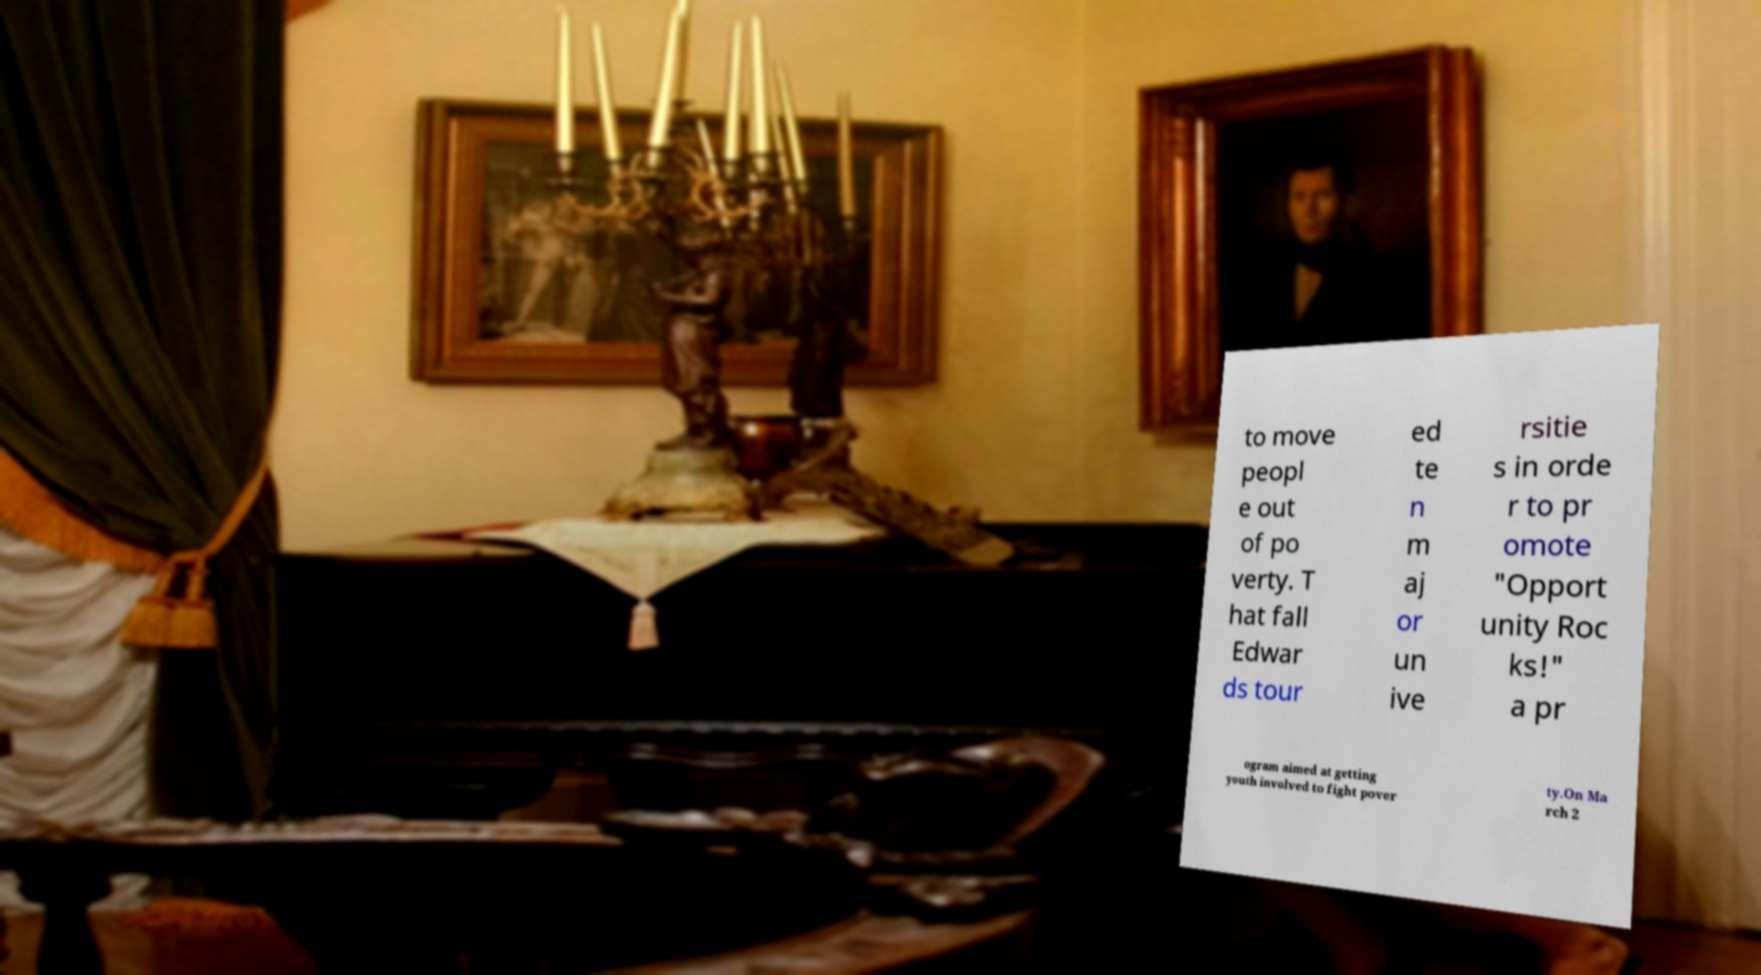Could you assist in decoding the text presented in this image and type it out clearly? to move peopl e out of po verty. T hat fall Edwar ds tour ed te n m aj or un ive rsitie s in orde r to pr omote "Opport unity Roc ks!" a pr ogram aimed at getting youth involved to fight pover ty.On Ma rch 2 